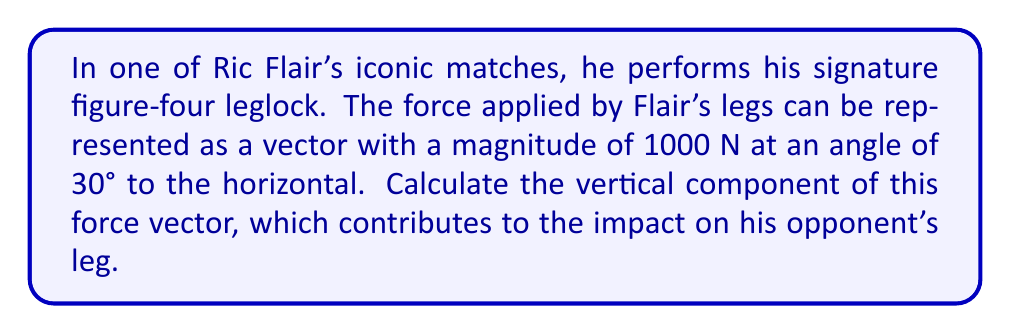Teach me how to tackle this problem. To solve this problem, we'll use trigonometric components of vectors. Here's the step-by-step solution:

1) The force vector can be broken down into horizontal and vertical components.

2) We're interested in the vertical component, which is given by the sine of the angle multiplied by the magnitude of the force.

3) The formula for the vertical component is:
   $$F_y = F \sin(\theta)$$
   Where $F_y$ is the vertical component, $F$ is the magnitude of the force, and $\theta$ is the angle to the horizontal.

4) We know:
   $F = 1000$ N
   $\theta = 30°$

5) Substituting these values:
   $$F_y = 1000 \sin(30°)$$

6) $\sin(30°) = 0.5$, so:
   $$F_y = 1000 \cdot 0.5 = 500$$

Therefore, the vertical component of Flair's force is 500 N.
Answer: 500 N 